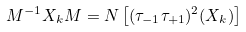<formula> <loc_0><loc_0><loc_500><loc_500>M ^ { - 1 } X _ { k } M = N \left [ ( \tau _ { - 1 } \tau _ { + 1 } ) ^ { 2 } ( X _ { k } ) \right ]</formula> 